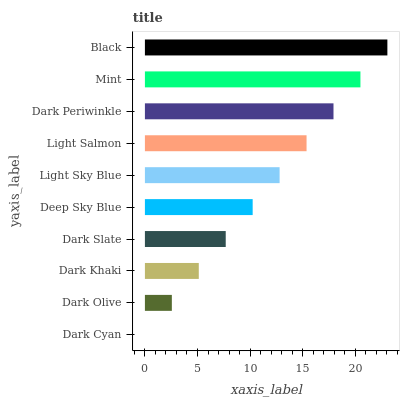Is Dark Cyan the minimum?
Answer yes or no. Yes. Is Black the maximum?
Answer yes or no. Yes. Is Dark Olive the minimum?
Answer yes or no. No. Is Dark Olive the maximum?
Answer yes or no. No. Is Dark Olive greater than Dark Cyan?
Answer yes or no. Yes. Is Dark Cyan less than Dark Olive?
Answer yes or no. Yes. Is Dark Cyan greater than Dark Olive?
Answer yes or no. No. Is Dark Olive less than Dark Cyan?
Answer yes or no. No. Is Light Sky Blue the high median?
Answer yes or no. Yes. Is Deep Sky Blue the low median?
Answer yes or no. Yes. Is Light Salmon the high median?
Answer yes or no. No. Is Dark Periwinkle the low median?
Answer yes or no. No. 